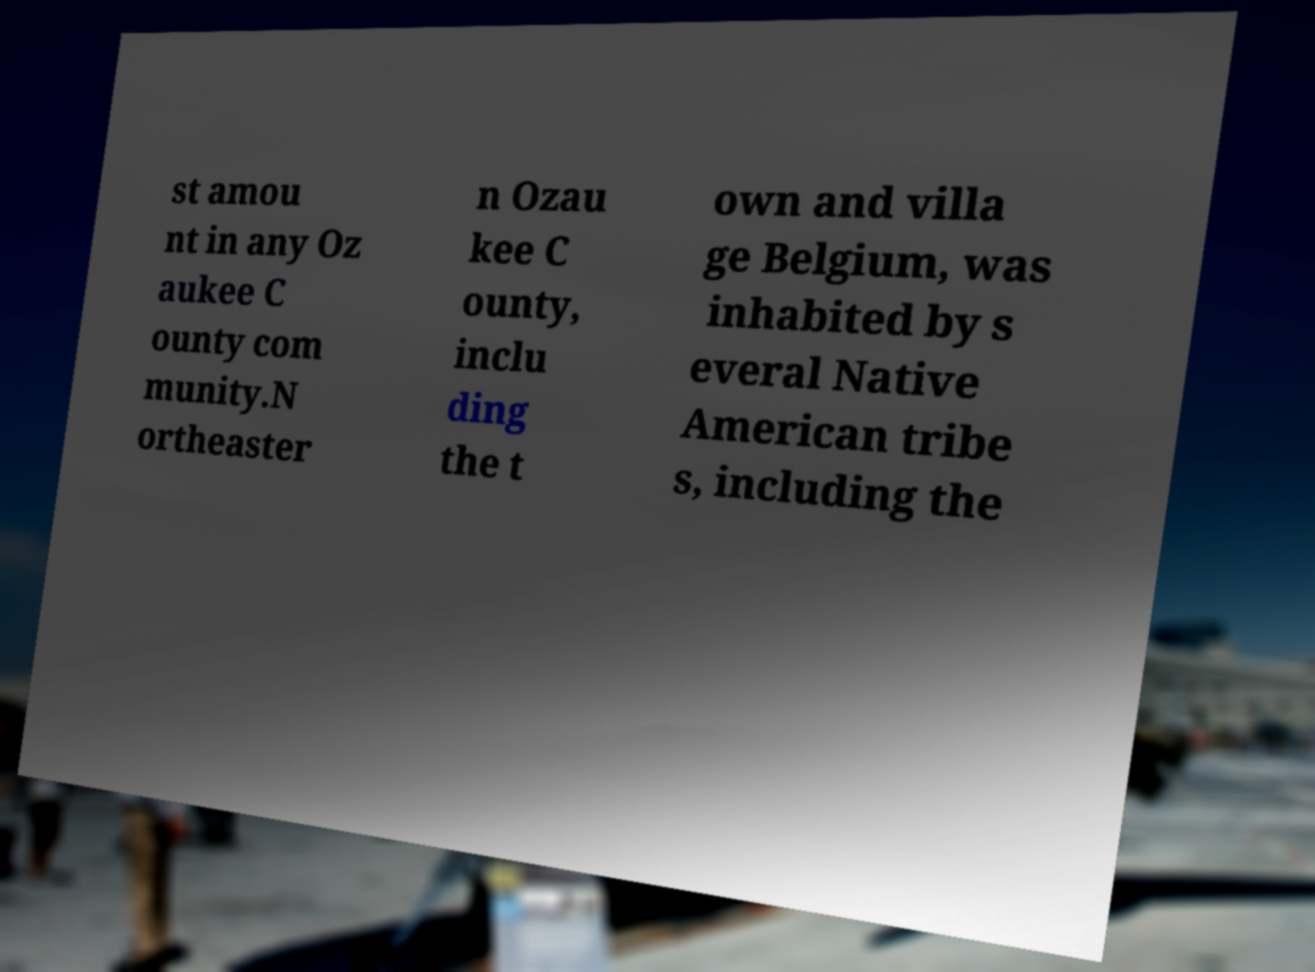There's text embedded in this image that I need extracted. Can you transcribe it verbatim? st amou nt in any Oz aukee C ounty com munity.N ortheaster n Ozau kee C ounty, inclu ding the t own and villa ge Belgium, was inhabited by s everal Native American tribe s, including the 